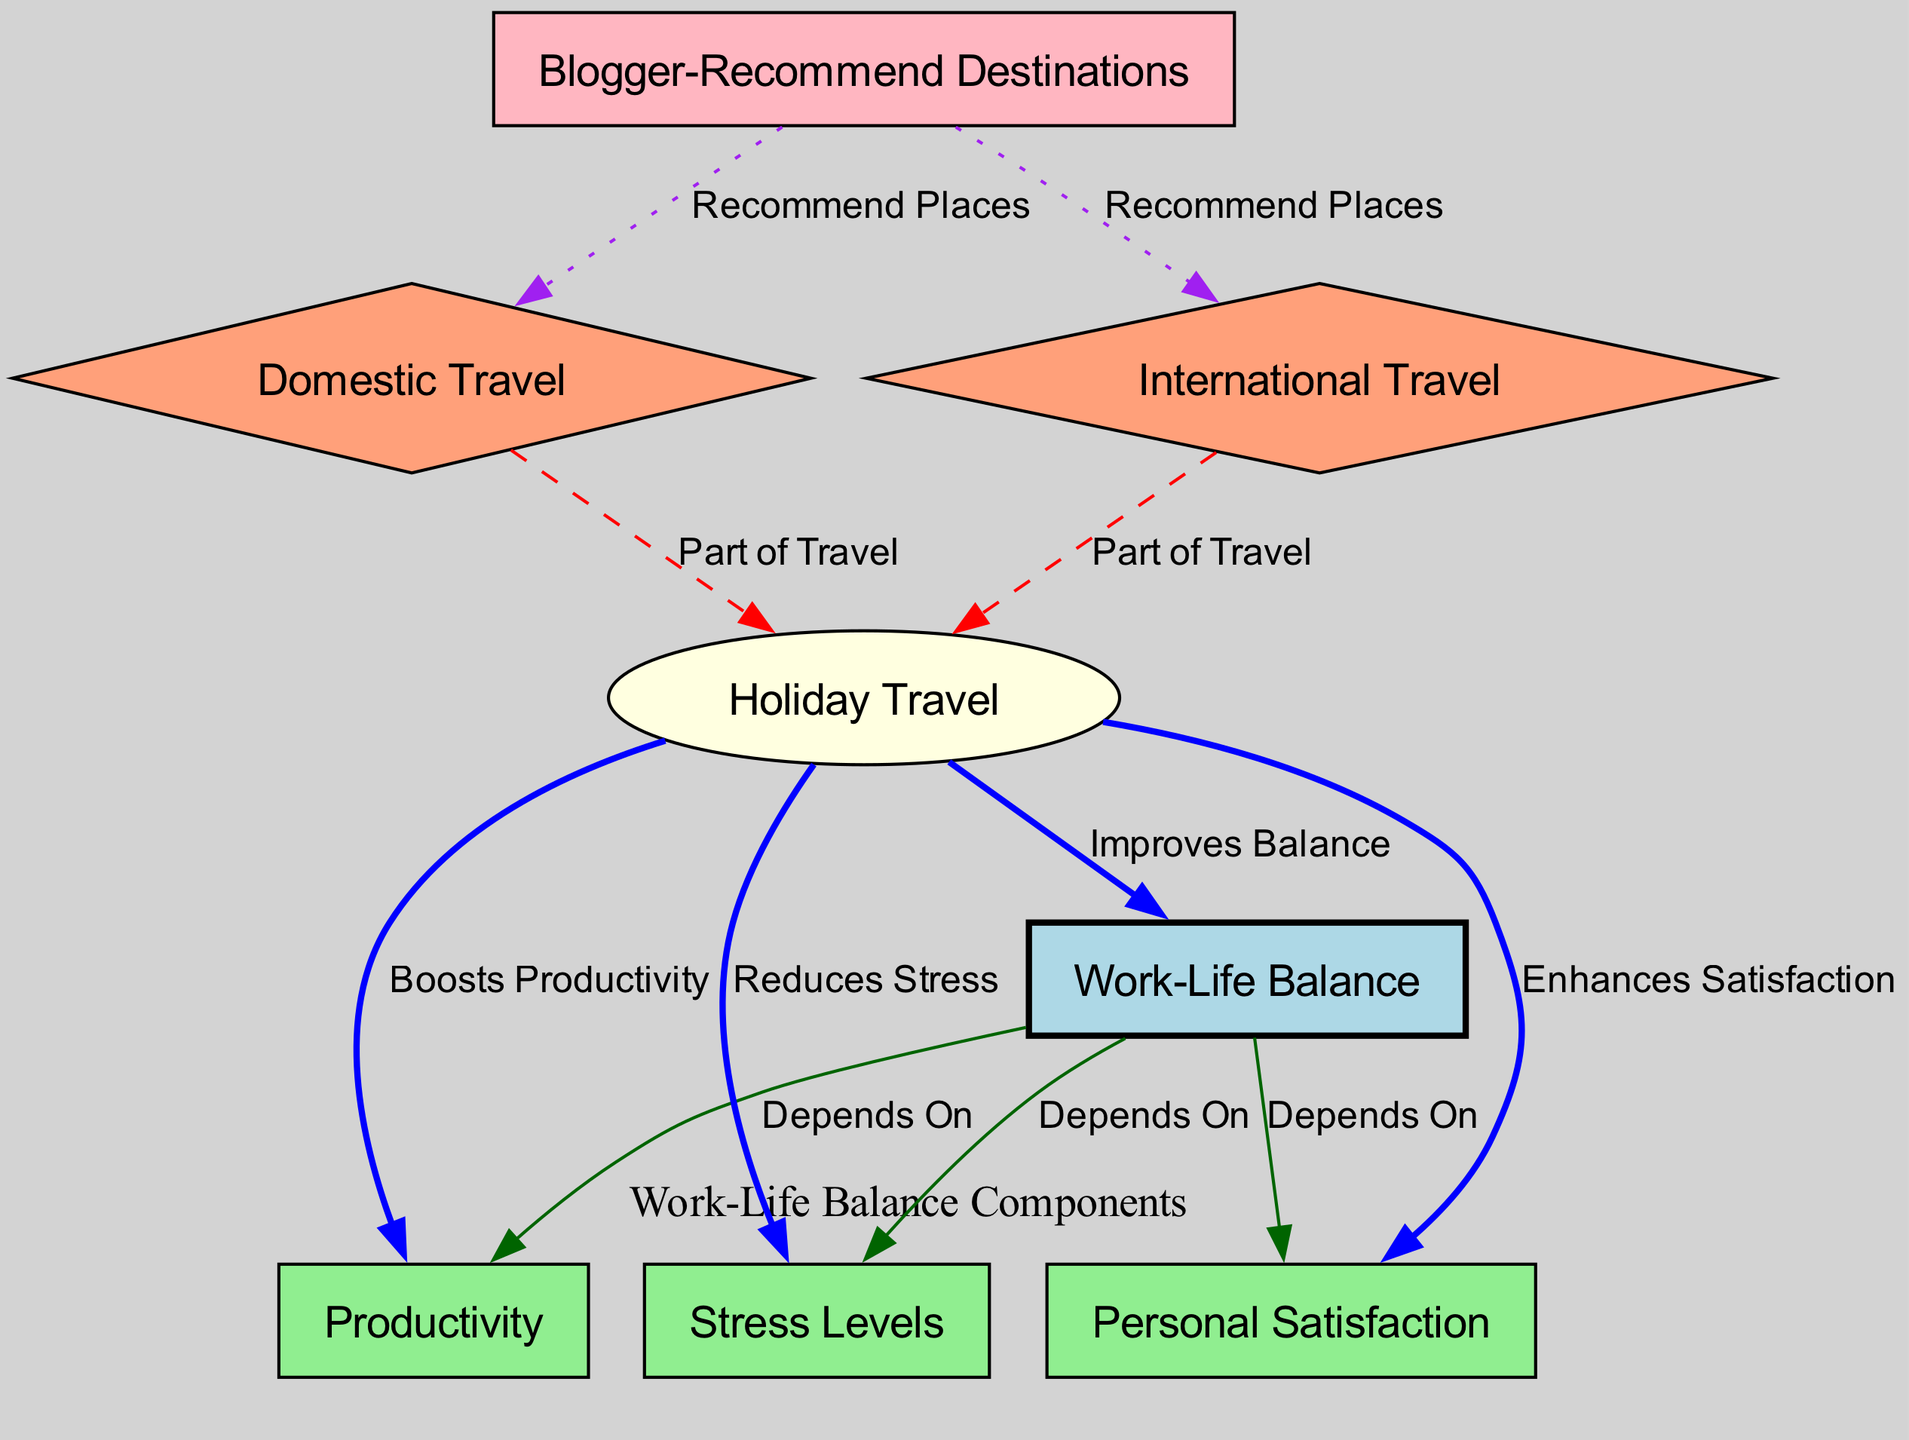What is the main focus of the diagram? The diagram primarily focuses on the "Impact of Travel on Work-Life Balance," which is indicated by the central node labeled "Work-Life Balance." This node connects to various aspects influenced by holiday travel.
Answer: Impact of Travel on Work-Life Balance How many nodes are present in the diagram? The diagram includes a total of eight nodes, all of which represent different aspects related to holiday travel and its effects on work-life balance. This includes nodes for productivity, stress levels, and personal satisfaction.
Answer: Eight What is the relationship between holiday travel and stress levels? The relationship is indicated by an edge labeled "Reduces Stress," connecting the "holiday travel" node to the "stress levels" node. This suggests that holiday travel has a positive influence on reducing stress.
Answer: Reduces Stress Which type of travel is represented as part of holiday travel? Both "Domestic Travel" and "International Travel" are represented as types of travel that contribute to "Holiday Travel," as indicated by dashed edges leading from these nodes to the "holiday travel" node.
Answer: Domestic Travel and International Travel What influences personal satisfaction according to the diagram? The diagram indicates that "personal satisfaction" is dependent on the "work-life balance," based on the edge labeled "Depends On" that connects these two nodes.
Answer: Work-Life Balance How does blogger-recommended destinations relate to travel types? The "blogger destinations" node has dotted edges leading to both "domestic travel" and "international travel," labeled "Recommend Places," showing that bloggers influence both types of travel.
Answer: Recommend Places What aspect of work-life balance is boosted by holiday travel? According to the diagram, "Productivity" is boosted by holiday travel, as indicated by the edge labeled "Boosts Productivity" connecting these two nodes.
Answer: Boosts Productivity How many edges connect work-life balance to its influencing factors? There are three edges connecting the "work_life_balance" node to "productivity," "stress_levels," and "personal_satisfaction," all labeled with "Depends On," indicating that these factors are influenced by work-life balance.
Answer: Three 